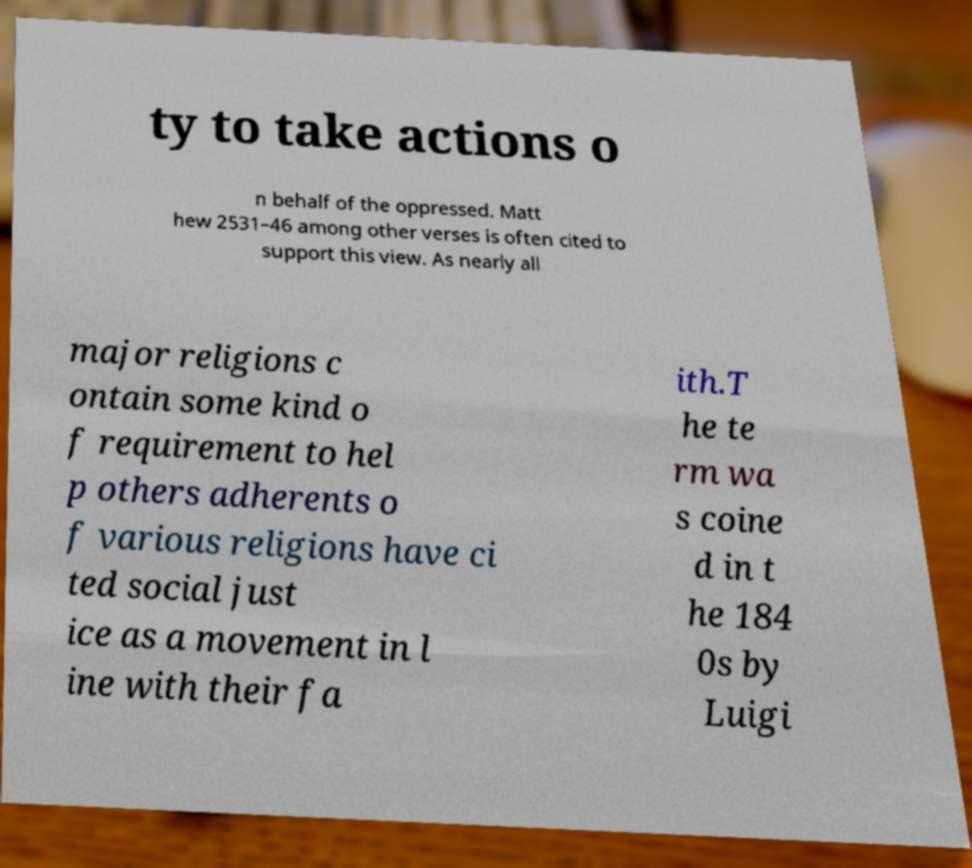Can you read and provide the text displayed in the image?This photo seems to have some interesting text. Can you extract and type it out for me? ty to take actions o n behalf of the oppressed. Matt hew 2531–46 among other verses is often cited to support this view. As nearly all major religions c ontain some kind o f requirement to hel p others adherents o f various religions have ci ted social just ice as a movement in l ine with their fa ith.T he te rm wa s coine d in t he 184 0s by Luigi 